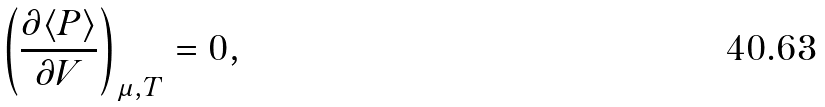Convert formula to latex. <formula><loc_0><loc_0><loc_500><loc_500>\left ( { \frac { \partial \langle P \rangle } { \partial V } } \right ) _ { \mu , T } = 0 ,</formula> 